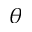Convert formula to latex. <formula><loc_0><loc_0><loc_500><loc_500>\theta</formula> 